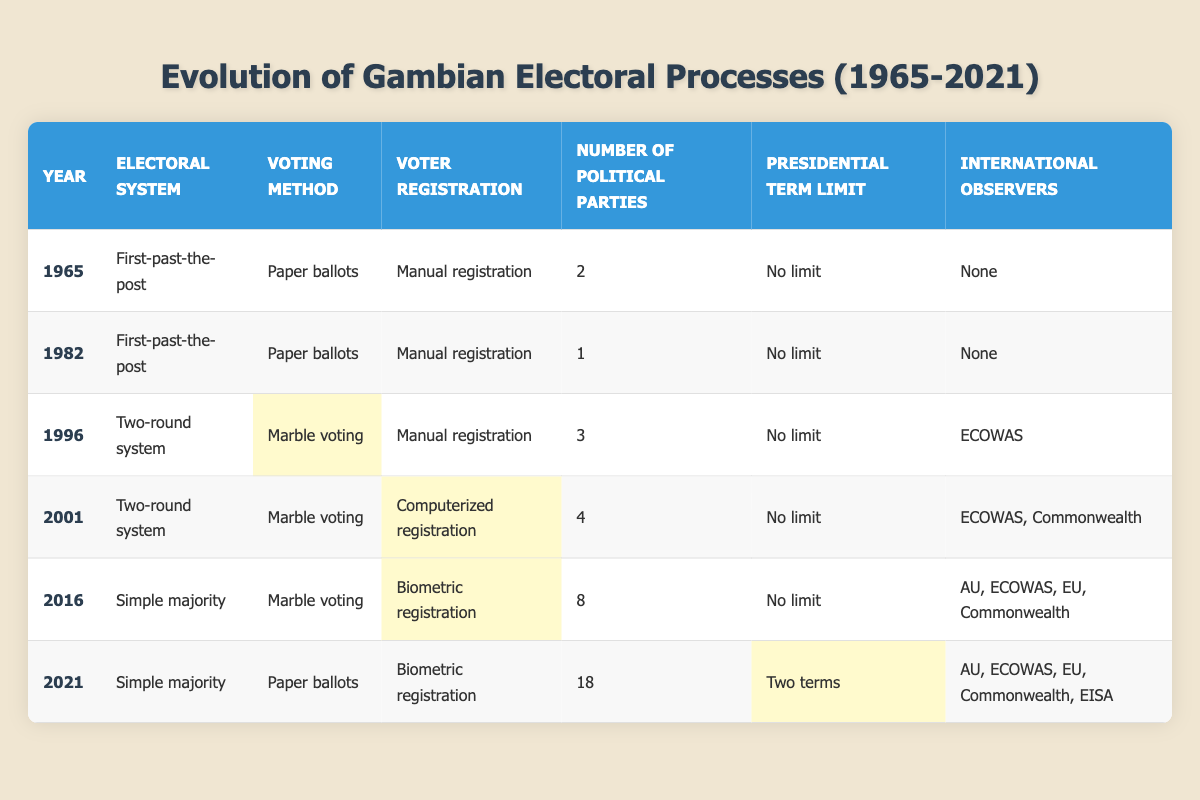What electoral system was used in The Gambia in 1982? In the table, under the "Year" column, locate the year 1982. The corresponding "Electoral System" value in that row is "First-past-the-post".
Answer: First-past-the-post How many political parties were there in 1996? The table shows that for the year 1996, the column "Number of Political Parties" lists "3".
Answer: 3 Was there a presidential term limit in 2001? In the 2001 row of the table, the "Presidential Term Limit" column states "No limit", indicating that there was no restriction on the number of terms a president could serve at that time.
Answer: No What is the difference in the number of political parties between 2016 and 2021? The table indicates that in 2016 there were "8" political parties, while in 2021 there were "18" political parties. The difference is calculated as 18 - 8 = 10.
Answer: 10 How many years had passed from the introduction of computerized registration until the introduction of biometric registration? The table shows that computerized registration was introduced in 2001 and biometric registration in 2016. The time difference is calculated as 2016 - 2001 = 15 years.
Answer: 15 years Which year had the highest number of international observers, and how many were there? Looking at the "International Observers" column, the year 2021 shows the highest count of international observers, listing "AU, ECOWAS, EU, Commonwealth, EISA", which amounts to 5 different groups.
Answer: 2021, 5 Did the electoral system change at all from 1996 to 2001? By checking the "Electoral System" column for 1996 ("Two-round system") and 2001 ("Two-round system"), we can confirm that the system did not change during those years.
Answer: No What voting methods were used in 2016 and 2021, and how do they differ? The "Voting Method" for 2016 is "Marble voting" and for 2021 it's "Paper ballots". This indicates a change in the voting method from marble voting to paper ballots between these years.
Answer: Different methods: Marble voting in 2016, Paper ballots in 2021 